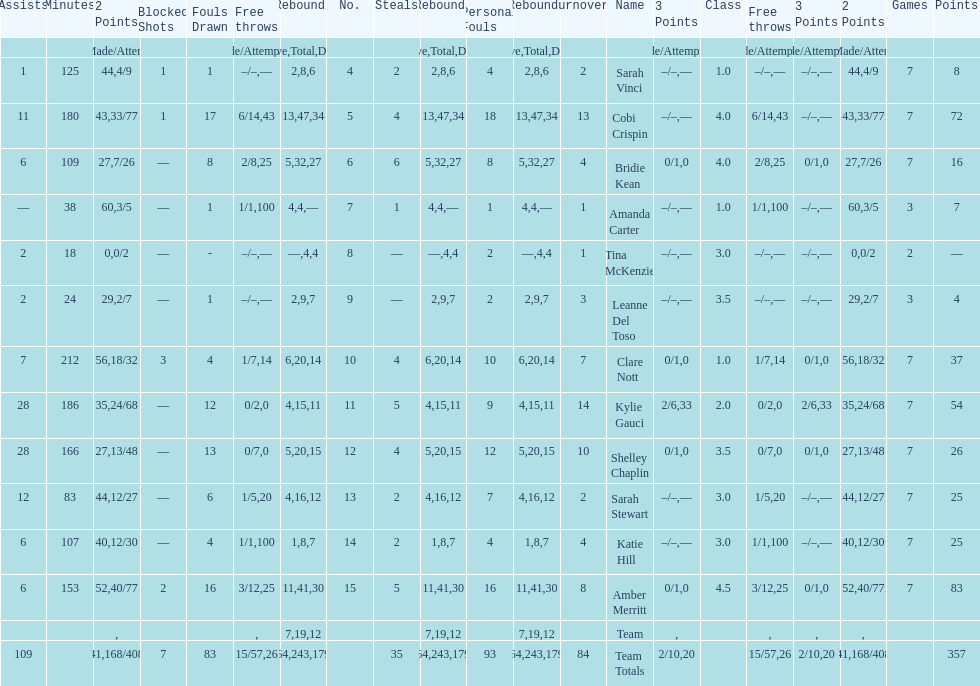Next to merritt, who was the top scorer? Cobi Crispin. 